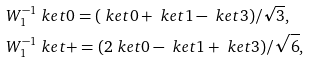Convert formula to latex. <formula><loc_0><loc_0><loc_500><loc_500>& W _ { 1 } ^ { - 1 } \ k e t { 0 } = ( \ k e t { 0 } + \ k e t { 1 } - \ k e t { 3 } ) / \sqrt { 3 } , \\ & W _ { 1 } ^ { - 1 } \ k e t { + } = ( 2 \ k e t { 0 } - \ k e t { 1 } + \ k e t { 3 } ) / \sqrt { 6 } ,</formula> 